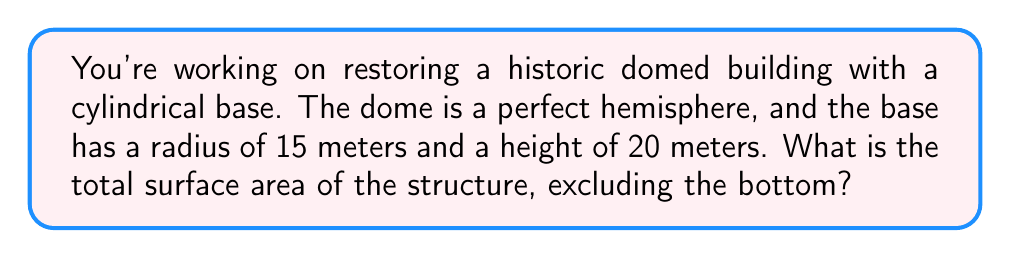Give your solution to this math problem. To solve this problem, we need to calculate the surface area of two parts: the cylindrical base and the hemispherical dome. Let's break it down step-by-step:

1. Cylindrical base:
   - Radius (r) = 15 m
   - Height (h) = 20 m
   - Surface area of cylinder (without top and bottom) = $2\pi rh$
   - $A_{cylinder} = 2\pi \cdot 15 \cdot 20 = 1800\pi$ m²

2. Hemispherical dome:
   - Radius (r) = 15 m (same as the base)
   - Surface area of a hemisphere = $2\pi r^2$
   - $A_{dome} = 2\pi \cdot 15^2 = 450\pi$ m²

3. Total surface area:
   - $A_{total} = A_{cylinder} + A_{dome}$
   - $A_{total} = 1800\pi + 450\pi = 2250\pi$ m²

To get the final answer in square meters, we need to calculate this:

$A_{total} = 2250\pi \approx 7068.58$ m²

This result is rounded to two decimal places.
Answer: The total surface area of the structure is approximately 7068.58 square meters. 